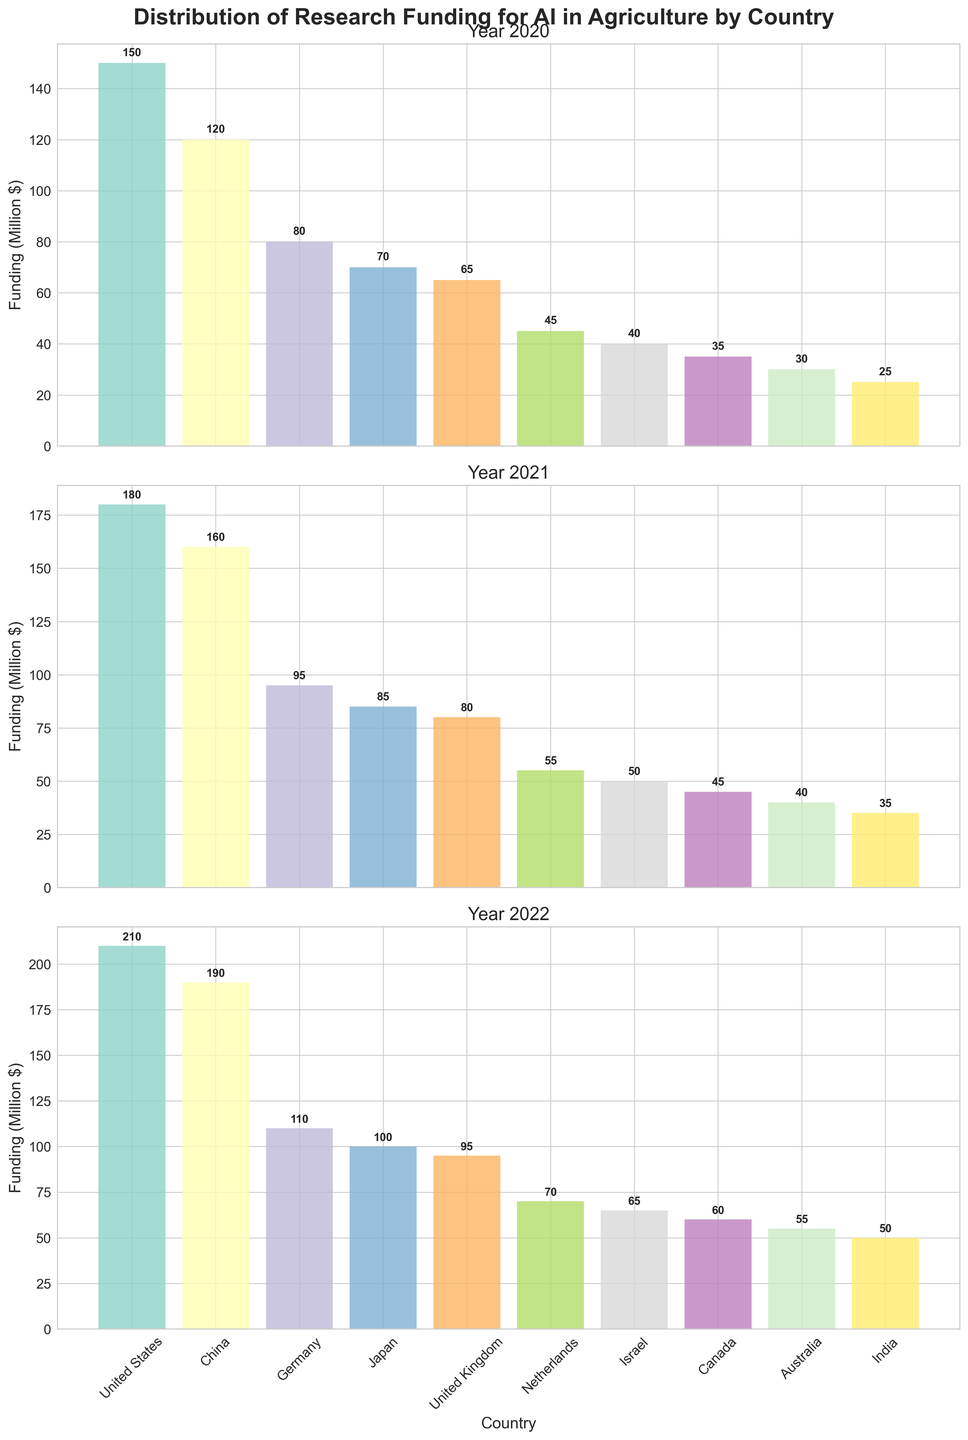What is the title of the figure? The title is typically the text in large, bold font at the top of the figure. It gives a summary of what the figure is about.
Answer: Distribution of Research Funding for AI in Agriculture by Country How many countries are represented in the figure? The number of countries represented can be counted by looking at the bars labeled along the x-axis for each subplot. There are ten country labels visible in each subplot.
Answer: Ten Which year had the highest funding for AI in agriculture for the United States? The funding amounts for the United States can be compared across the three subplots (2020, 2021, 2022). The 2022 bar for the United States is the highest among them.
Answer: 2022 What is the total funding for AI in agriculture for China over the three years? To get the total funding, sum up the funding amounts for China from all three years: 120 (2020) + 160 (2021) + 190 (2022).
Answer: 470 Which country had the lowest funding in the year 2020? The country with the smallest bar in the 2020 subplot (first subplot) represents the country with the lowest funding.
Answer: India Was there a year where Japan's funding was less than that of Germany? To answer, compare the heights of the bars for Japan and Germany in each year (subplot). In every year, Germany's bar is higher than Japan's.
Answer: No How does the funding trend for the United Kingdom change over the three years? By observing the height of the bars for the United Kingdom across the three subplots, you can see an increase each year: 65 (2020), 80 (2021), 95 (2022).
Answer: Increasing Which country had the second highest funding in 2021? By looking at the 2021 subplot, find the second tallest bar, which belongs to the United States for that year.
Answer: United States How much more funding did Australia receive in 2022 compared to 2020? Subtract the funding amount for Australia in 2020 (30) from the amount in 2022 (55). 55 - 30 = 25.
Answer: 25 Between Canada and Israel, which country saw a greater increase in funding from 2020 to 2022? Compare the funding increases for both countries: Israel's increase is 25 (65 - 40), and Canada's increase is 25 (60 - 35). Both increases are equal.
Answer: Equal 